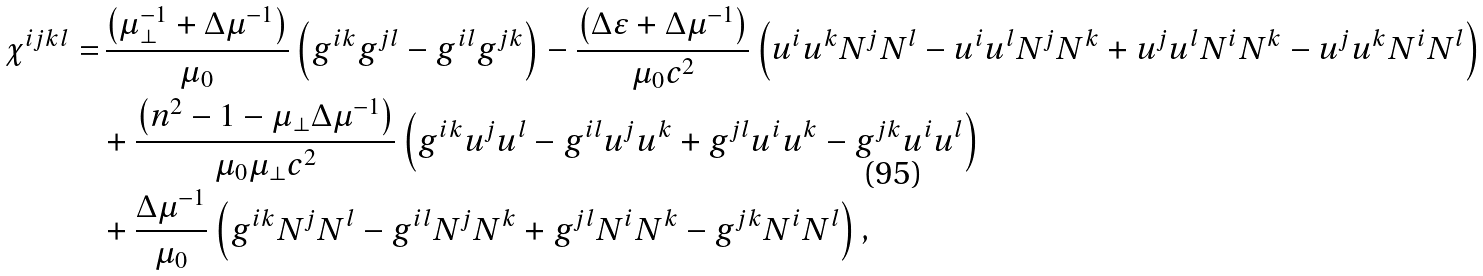<formula> <loc_0><loc_0><loc_500><loc_500>\chi ^ { i j k l } = & \, \frac { \left ( \mu ^ { - 1 } _ { \perp } + \Delta \mu ^ { - 1 } \right ) } { \mu _ { 0 } } \left ( g ^ { i k } g ^ { j l } - g ^ { i l } g ^ { j k } \right ) - \frac { \left ( \Delta \varepsilon + \Delta \mu ^ { - 1 } \right ) } { \mu _ { 0 } c ^ { 2 } } \left ( u ^ { i } u ^ { k } N ^ { j } N ^ { l } - u ^ { i } u ^ { l } N ^ { j } N ^ { k } + u ^ { j } u ^ { l } N ^ { i } N ^ { k } - u ^ { j } u ^ { k } N ^ { i } N ^ { l } \right ) \\ & + \frac { \left ( n ^ { 2 } - 1 - \mu _ { \perp } \Delta \mu ^ { - 1 } \right ) } { \mu _ { 0 } \mu _ { \perp } c ^ { 2 } } \left ( g ^ { i k } u ^ { j } u ^ { l } - g ^ { i l } u ^ { j } u ^ { k } + g ^ { j l } u ^ { i } u ^ { k } - g ^ { j k } u ^ { i } u ^ { l } \right ) \\ & + \frac { \Delta \mu ^ { - 1 } } { \mu _ { 0 } } \left ( g ^ { i k } N ^ { j } N ^ { l } - g ^ { i l } N ^ { j } N ^ { k } + g ^ { j l } N ^ { i } N ^ { k } - g ^ { j k } N ^ { i } N ^ { l } \right ) ,</formula> 